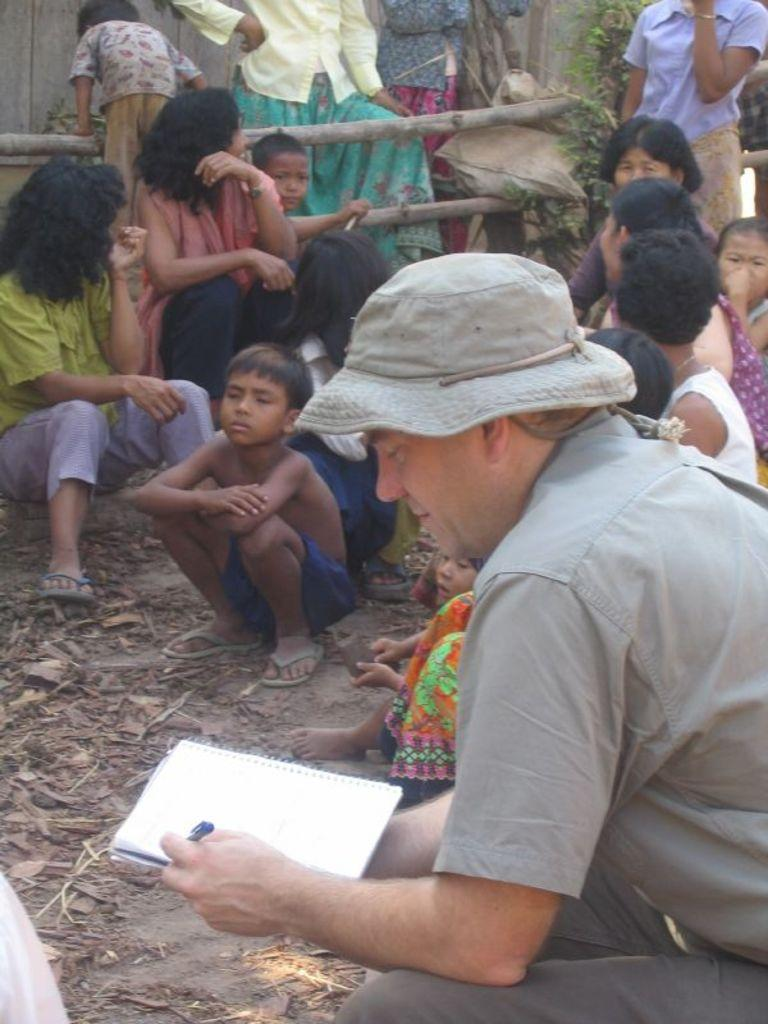How many people are in the image? There is a group of people in the image. Can you describe the man in the front? The man in the front is wearing a hat and holding a book in his hands. What type of crate is the man in the front using to store his memories? There is no crate present in the image, and the man is not storing any memories. 